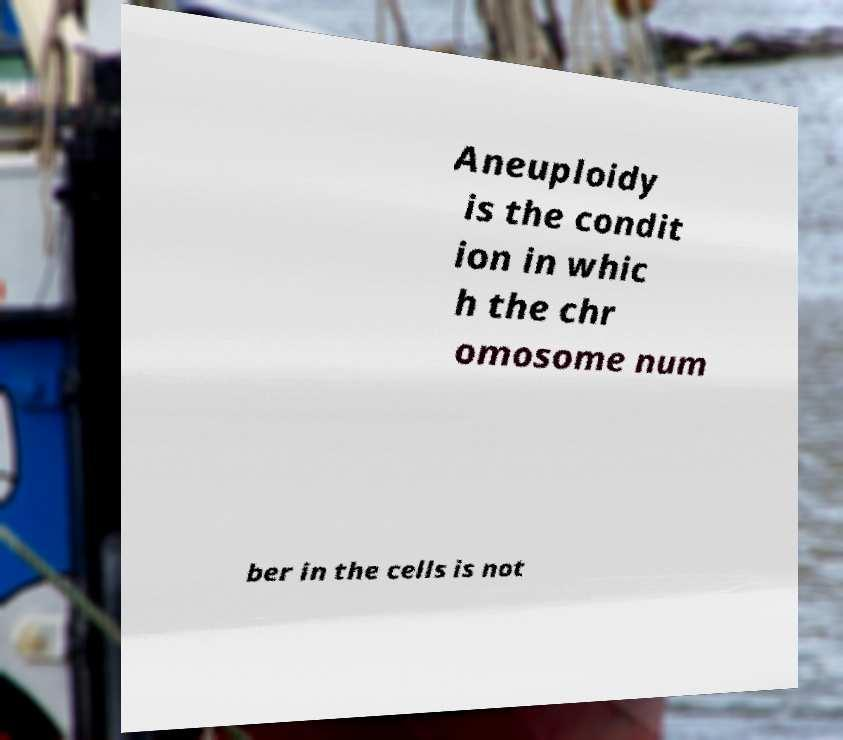Can you read and provide the text displayed in the image?This photo seems to have some interesting text. Can you extract and type it out for me? Aneuploidy is the condit ion in whic h the chr omosome num ber in the cells is not 